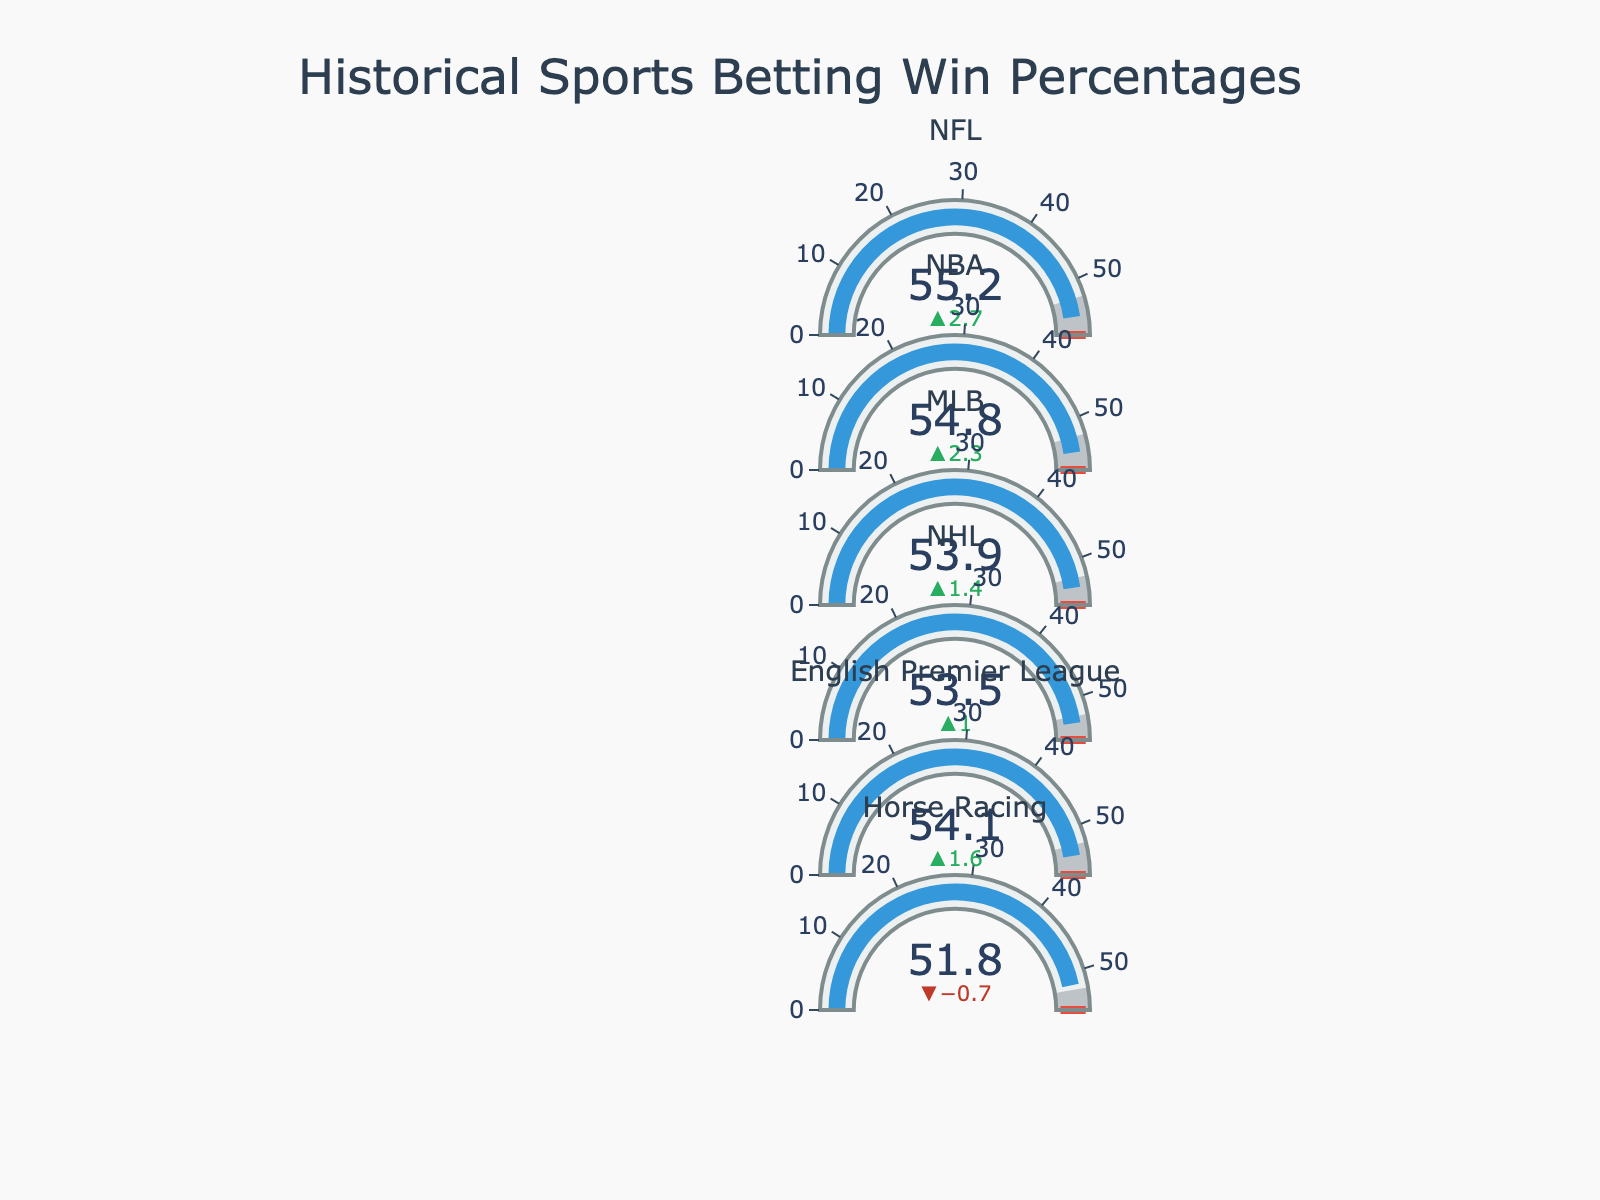What's the title of this figure? The title is usually displayed at the top of the figure. For this chart, it reads "Historical Sports Betting Win Percentages".
Answer: Historical Sports Betting Win Percentages How many leagues are represented in the chart? We can count the different league names displayed on the y-axis of the chart. If we go through them, we have NFL, NBA, MLB, NHL, English Premier League, and Horse Racing.
Answer: 6 What is the actual win percentage for the NFL? Find the indicator labeled with "NFL" and look at the value displayed in the main portion of that gauge. It shows "55.2%".
Answer: 55.2% Which league has the lowest actual win percentage? By scanning through each league's actual win percentage, we see that Horse Racing has the lowest value at "51.8%".
Answer: Horse Racing Which leagues have an actual win percentage above the industry benchmark of 52.5%? Compare the actual win percentage of each league with the benchmark. All leagues except Horse Racing (51.8%) are above the industry benchmark.
Answer: NFL, NBA, MLB, NHL, English Premier League What is the average actual win percentage across all leagues? Sum up all actual win percentages and divide by the number of leagues: (55.2 + 54.8 + 53.9 + 53.5 + 54.1 + 51.8) / 6 = 323.3 / 6 = 53.88%.
Answer: 53.88% How much higher is the NFL's actual win percentage compared to its industry benchmark? Look at the NFL's actual win percentage (55.2%) and subtract the benchmark (52.5%). This gives us 55.2% - 52.5% = 2.7%.
Answer: 2.7% Which league comes closest to achieving its exceptional performance mark? Compare the actual win percentage and the exceptional performance mark for each league to see the smallest gap. The NBA has a 54.8% win percentage with an exceptional mark at 57.5%, creating a gap of 2.7%.
Answer: NBA Are there any leagues where the actual win percentage is below the industry benchmark? Check all leagues' actual win percentages against the benchmark of 52.5%. Only Horse Racing (51.8%) falls below this mark.
Answer: Yes, Horse Racing 